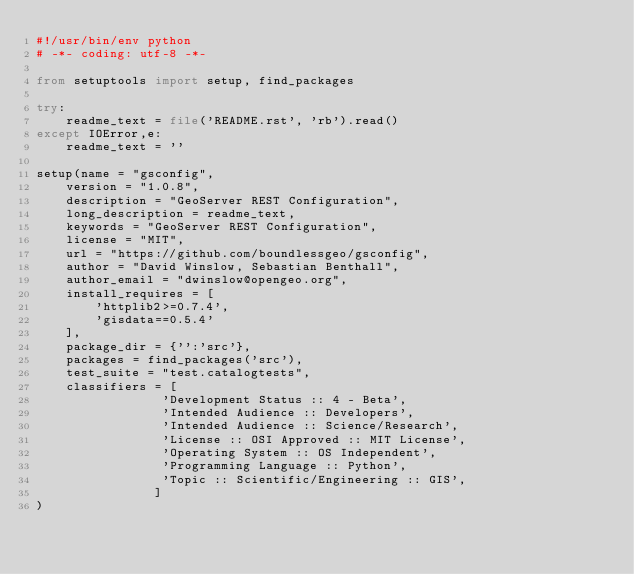Convert code to text. <code><loc_0><loc_0><loc_500><loc_500><_Python_>#!/usr/bin/env python
# -*- coding: utf-8 -*-

from setuptools import setup, find_packages

try:
    readme_text = file('README.rst', 'rb').read()
except IOError,e:
    readme_text = ''

setup(name = "gsconfig",
    version = "1.0.8",
    description = "GeoServer REST Configuration",
    long_description = readme_text,
    keywords = "GeoServer REST Configuration",
    license = "MIT",
    url = "https://github.com/boundlessgeo/gsconfig",
    author = "David Winslow, Sebastian Benthall",
    author_email = "dwinslow@opengeo.org",
    install_requires = [
        'httplib2>=0.7.4',
        'gisdata==0.5.4'
    ],
    package_dir = {'':'src'},
    packages = find_packages('src'),
    test_suite = "test.catalogtests",
    classifiers = [
                 'Development Status :: 4 - Beta',
                 'Intended Audience :: Developers',
                 'Intended Audience :: Science/Research',
                 'License :: OSI Approved :: MIT License',
                 'Operating System :: OS Independent',
                 'Programming Language :: Python',
                 'Topic :: Scientific/Engineering :: GIS',
                ]
)
</code> 